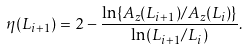Convert formula to latex. <formula><loc_0><loc_0><loc_500><loc_500>\eta ( L _ { i + 1 } ) = 2 - \frac { \ln \{ A _ { z } ( L _ { i + 1 } ) / A _ { z } ( L _ { i } ) \} } { \ln ( L _ { i + 1 } / L _ { i } ) } .</formula> 